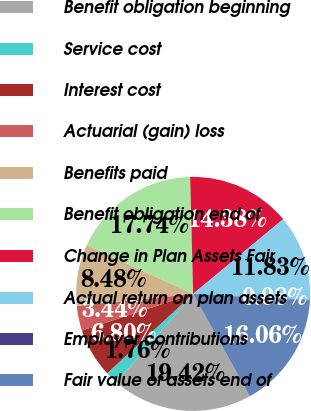<chart> <loc_0><loc_0><loc_500><loc_500><pie_chart><fcel>Benefit obligation beginning<fcel>Service cost<fcel>Interest cost<fcel>Actuarial (gain) loss<fcel>Benefits paid<fcel>Benefit obligation end of<fcel>Change in Plan Assets Fair<fcel>Actual return on plan assets<fcel>Employer contributions<fcel>Fair value of assets end of<nl><fcel>19.42%<fcel>1.76%<fcel>6.8%<fcel>3.44%<fcel>8.48%<fcel>17.74%<fcel>14.38%<fcel>11.83%<fcel>0.08%<fcel>16.06%<nl></chart> 